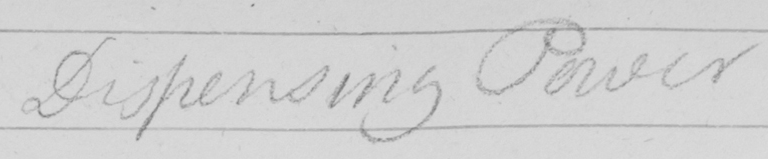Can you read and transcribe this handwriting? Dispensing Power 